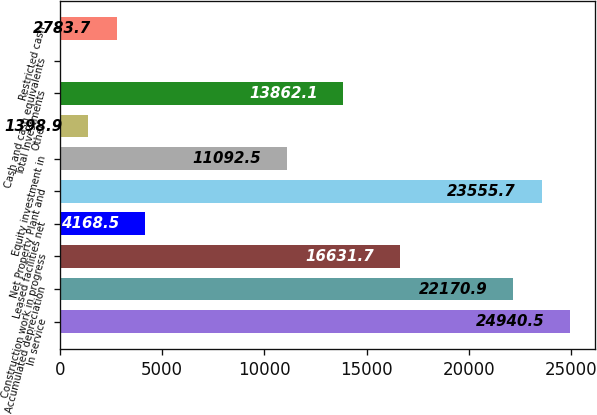Convert chart to OTSL. <chart><loc_0><loc_0><loc_500><loc_500><bar_chart><fcel>In service<fcel>Accumulated depreciation<fcel>Construction work in progress<fcel>Leased facilities net<fcel>Net Property Plant and<fcel>Equity investment in<fcel>Other<fcel>Total Investments<fcel>Cash and cash equivalents<fcel>Restricted cash<nl><fcel>24940.5<fcel>22170.9<fcel>16631.7<fcel>4168.5<fcel>23555.7<fcel>11092.5<fcel>1398.9<fcel>13862.1<fcel>14.1<fcel>2783.7<nl></chart> 